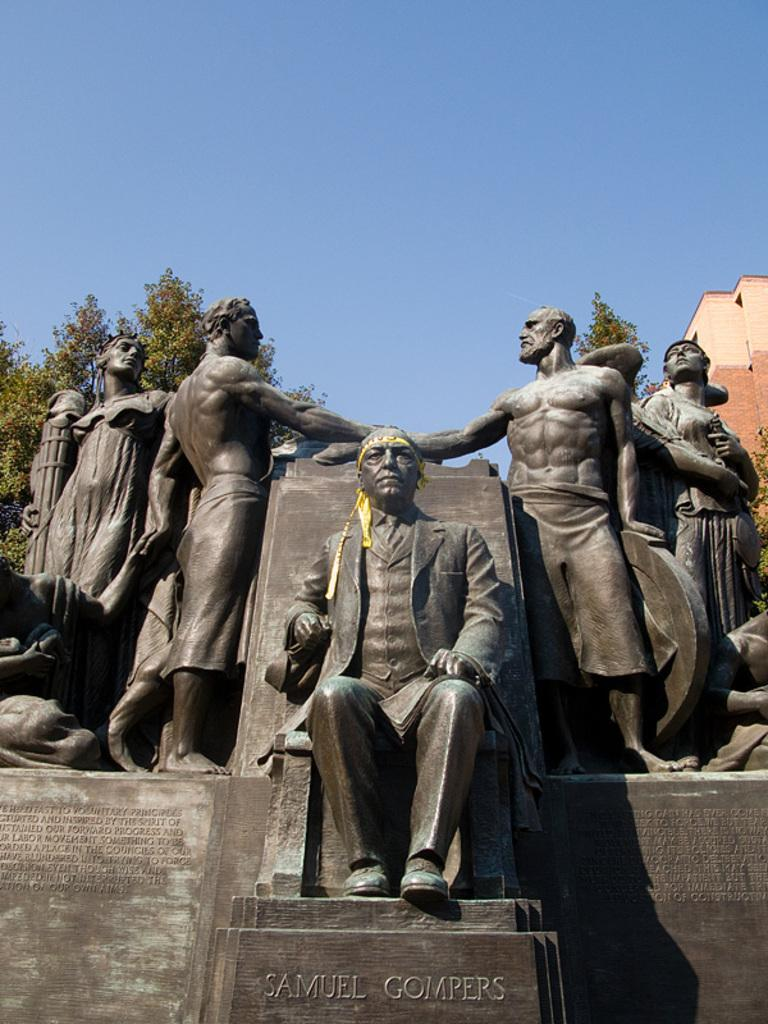What is depicted in the image? There are sculptures of five persons in the image. Are there any words or letters in the image? Yes, there is text in the image. What can be seen in the background of the image? There are trees, a building, and the sky visible in the background of the image. Can you determine the time of day the image was taken? The image was likely taken during the day, as the sky is visible. What type of cord is being used for the discussion in the image? There is no discussion or cord present in the image; it features sculptures of five persons, text, and a background with trees, a building, and the sky. 